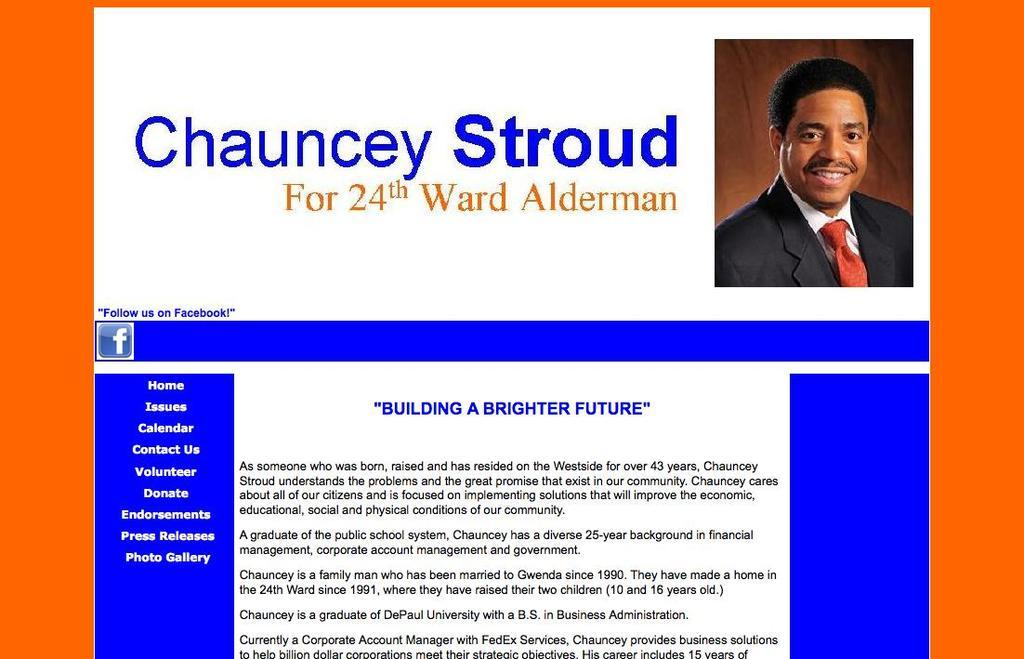What is the main feature of the image? There is a title and some text in the image. Can you describe the photograph in the image? There is a photograph of a person on the right side of the image. What type of page might this image represent? The image appears to be the home page of a website. Are there any cobwebs visible in the image? There are no cobwebs present in the image. What type of yard can be seen in the image? There is no yard visible in the image; it primarily features text, a title, and a photograph. 